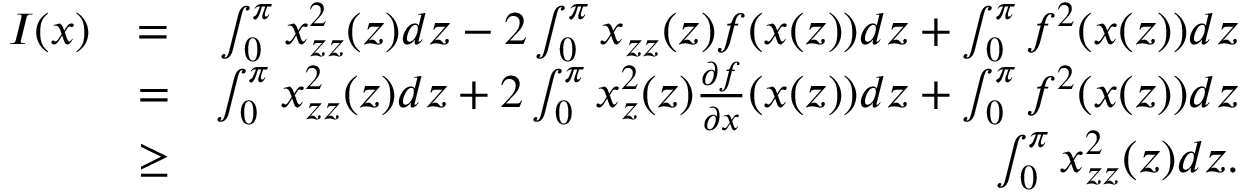<formula> <loc_0><loc_0><loc_500><loc_500>\begin{array} { r l r } { I ( x ) } & { = } & { \int _ { 0 } ^ { \pi } x _ { z z } ^ { 2 } ( z ) d z - 2 \int _ { 0 } ^ { \pi } x _ { z z } ( z ) f ( x ( z ) ) d z + \int _ { 0 } ^ { \pi } f ^ { 2 } ( x ( z ) ) d z } \\ & { = } & { \int _ { 0 } ^ { \pi } x _ { z z } ^ { 2 } ( z ) d z + 2 \int _ { 0 } ^ { \pi } x _ { z } ^ { 2 } ( z ) \frac { \partial f } { \partial x } ( x ( z ) ) d z + \int _ { 0 } ^ { \pi } { f ^ { 2 } ( x ( z ) ) d z } } \\ & { \geq } & { \int _ { 0 } ^ { \pi } x _ { z z } ^ { 2 } ( z ) d z . } \end{array}</formula> 